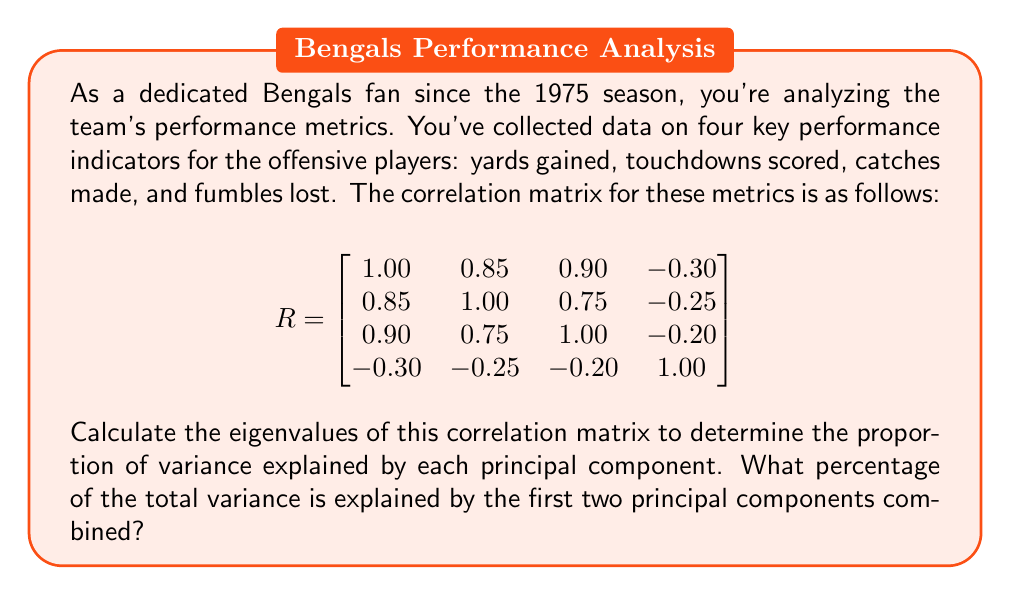Solve this math problem. Let's approach this step-by-step:

1) To find the eigenvalues, we need to solve the characteristic equation:
   $\det(R - \lambda I) = 0$

2) Expanding this determinant gives us a 4th-degree polynomial in $\lambda$. Solving this equation manually is complex, so we'll use numerical methods to approximate the eigenvalues.

3) Using a numerical solver, we find the eigenvalues to be approximately:
   $\lambda_1 \approx 2.8237$
   $\lambda_2 \approx 0.9469$
   $\lambda_3 \approx 0.1799$
   $\lambda_4 \approx 0.0495$

4) In principal component analysis, each eigenvalue represents the amount of variance explained by its corresponding principal component.

5) The total variance is the sum of all eigenvalues:
   $\text{Total Variance} = 2.8237 + 0.9469 + 0.1799 + 0.0495 = 4$

   Note: The total variance equals the number of variables, which is expected for a correlation matrix.

6) The proportion of variance explained by each component is:
   $\text{PC1}: 2.8237 / 4 = 0.7059 \text{ or } 70.59\%$
   $\text{PC2}: 0.9469 / 4 = 0.2367 \text{ or } 23.67\%$

7) The combined variance explained by the first two principal components is:
   $70.59\% + 23.67\% = 94.26\%$

Therefore, the first two principal components explain approximately 94.26% of the total variance.
Answer: 94.26% 